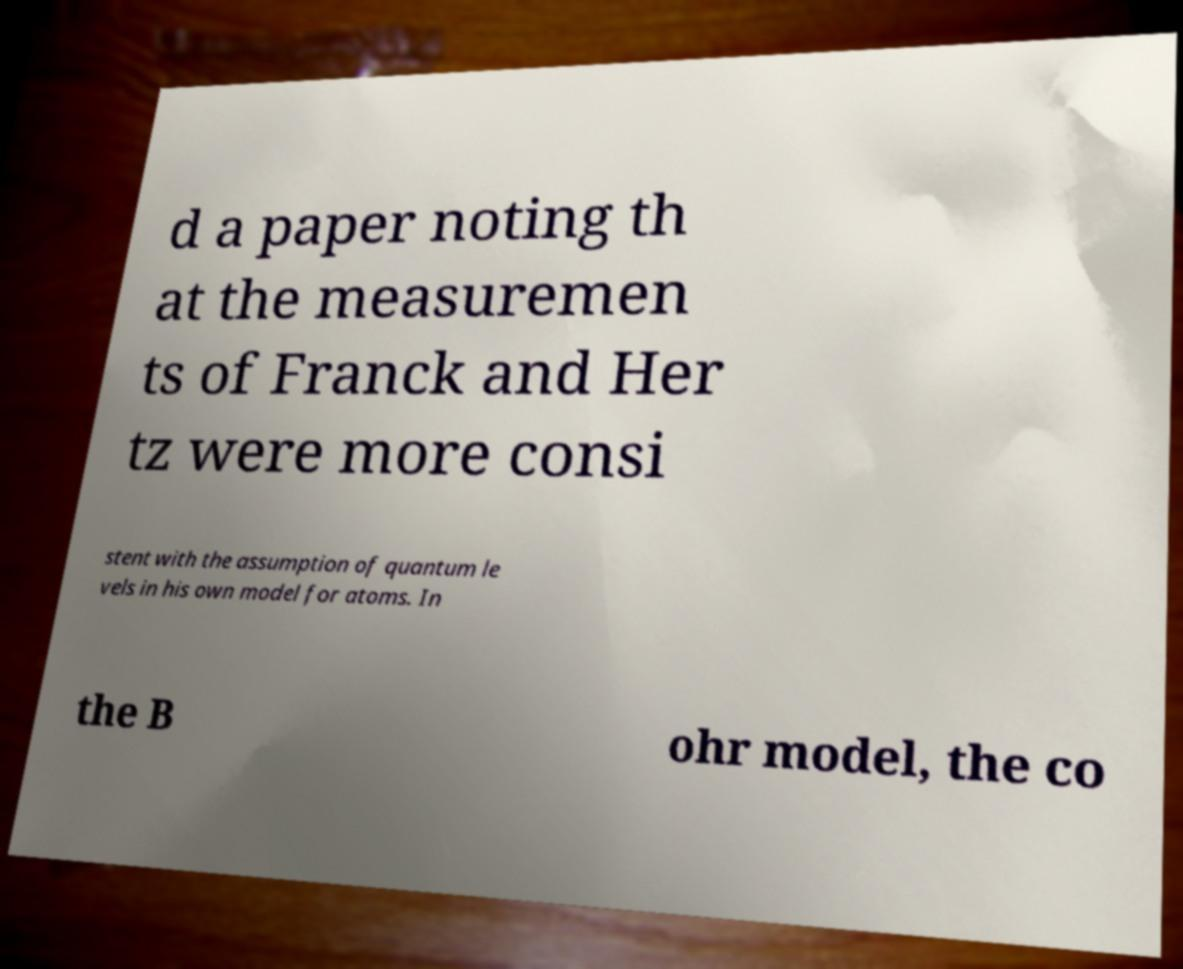I need the written content from this picture converted into text. Can you do that? d a paper noting th at the measuremen ts of Franck and Her tz were more consi stent with the assumption of quantum le vels in his own model for atoms. In the B ohr model, the co 